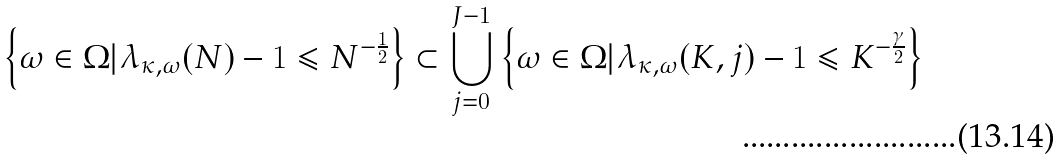Convert formula to latex. <formula><loc_0><loc_0><loc_500><loc_500>\left \{ \omega \in \Omega | \lambda _ { \kappa , \omega } ( N ) - 1 \leqslant N ^ { - \frac { 1 } { 2 } } \right \} & \subset \bigcup _ { j = 0 } ^ { J - 1 } \left \{ \omega \in \Omega | \lambda _ { \kappa , \omega } ( K , j ) - 1 \leqslant K ^ { - \frac { \gamma } { 2 } } \right \}</formula> 